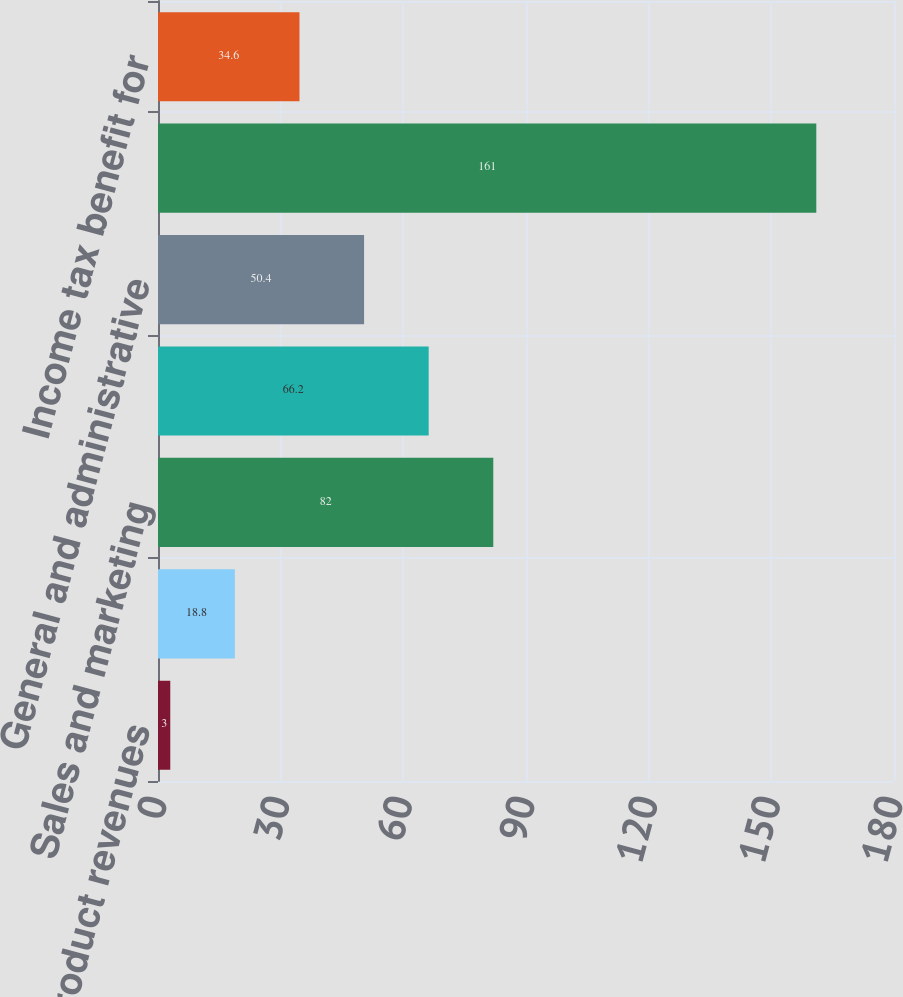Convert chart to OTSL. <chart><loc_0><loc_0><loc_500><loc_500><bar_chart><fcel>Cost of product revenues<fcel>Cost of hardware maintenance<fcel>Sales and marketing<fcel>Research and development<fcel>General and administrative<fcel>Total stock-based compensation<fcel>Income tax benefit for<nl><fcel>3<fcel>18.8<fcel>82<fcel>66.2<fcel>50.4<fcel>161<fcel>34.6<nl></chart> 